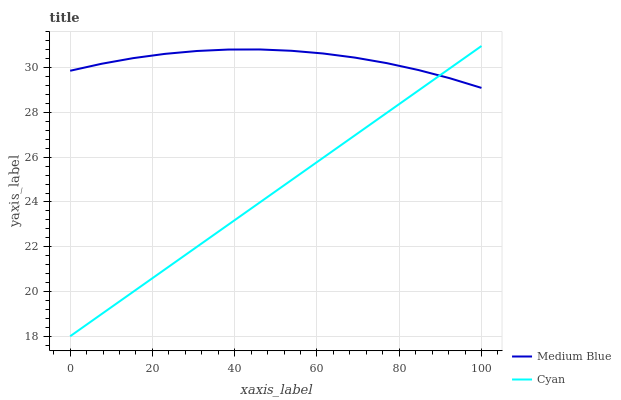Does Cyan have the minimum area under the curve?
Answer yes or no. Yes. Does Medium Blue have the maximum area under the curve?
Answer yes or no. Yes. Does Medium Blue have the minimum area under the curve?
Answer yes or no. No. Is Cyan the smoothest?
Answer yes or no. Yes. Is Medium Blue the roughest?
Answer yes or no. Yes. Is Medium Blue the smoothest?
Answer yes or no. No. Does Medium Blue have the lowest value?
Answer yes or no. No. Does Medium Blue have the highest value?
Answer yes or no. No. 